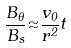<formula> <loc_0><loc_0><loc_500><loc_500>\frac { B _ { \theta } } { B _ { s } } { \approx } \frac { { v _ { 0 } } } { r ^ { 2 } } t</formula> 